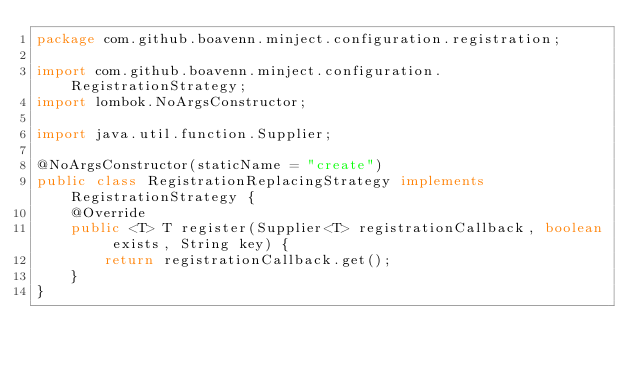<code> <loc_0><loc_0><loc_500><loc_500><_Java_>package com.github.boavenn.minject.configuration.registration;

import com.github.boavenn.minject.configuration.RegistrationStrategy;
import lombok.NoArgsConstructor;

import java.util.function.Supplier;

@NoArgsConstructor(staticName = "create")
public class RegistrationReplacingStrategy implements RegistrationStrategy {
    @Override
    public <T> T register(Supplier<T> registrationCallback, boolean exists, String key) {
        return registrationCallback.get();
    }
}
</code> 